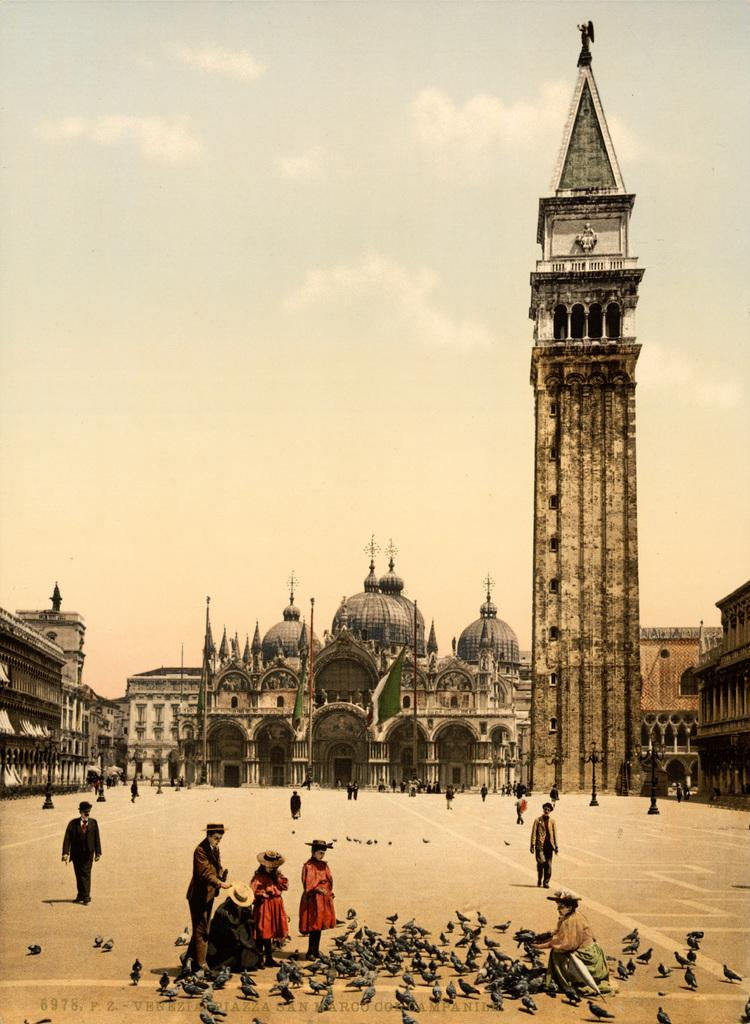Who are the subjects in the image? There are people in the image. What are the people doing in the image? The people are feeding birds. Where are the birds located in the image? The birds are on the road. What can be seen in the background of the image? There are buildings visible in the background of the image. What flavor of sand can be seen in the image? There is no sand present in the image, so it is not possible to determine the flavor of any sand. 